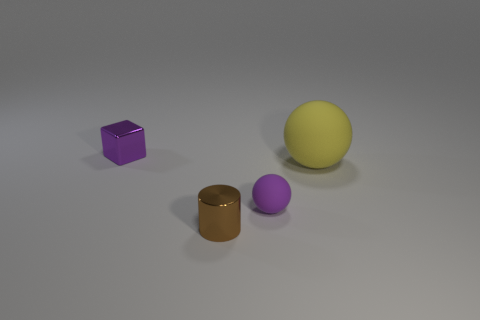Add 4 big brown things. How many objects exist? 8 Subtract all purple balls. How many balls are left? 1 Add 2 big yellow objects. How many big yellow objects exist? 3 Subtract 0 yellow cylinders. How many objects are left? 4 Subtract all cylinders. How many objects are left? 3 Subtract all brown spheres. Subtract all red cylinders. How many spheres are left? 2 Subtract all purple blocks. How many yellow balls are left? 1 Subtract all big gray cylinders. Subtract all large matte balls. How many objects are left? 3 Add 4 purple cubes. How many purple cubes are left? 5 